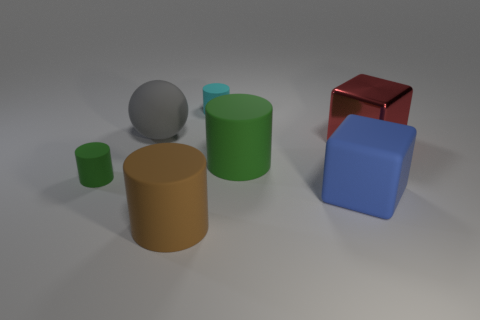Add 2 gray shiny cubes. How many objects exist? 9 Subtract all cubes. How many objects are left? 5 Subtract 0 yellow cylinders. How many objects are left? 7 Subtract all big green shiny objects. Subtract all cyan objects. How many objects are left? 6 Add 1 brown cylinders. How many brown cylinders are left? 2 Add 4 big blue cubes. How many big blue cubes exist? 5 